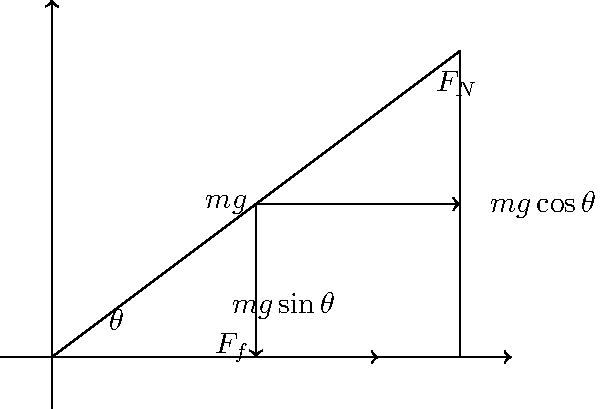In the context of teaching language through literature, consider a story about a refugee's journey up a steep hill. To help students understand the physical challenges faced by the character, explain the forces acting on an object (representing the refugee) on an inclined plane with angle $\theta$. If the coefficient of friction is $\mu$, what is the minimum angle $\theta$ required for the object to slide down the incline? Let's break this down step-by-step:

1) The forces acting on the object are:
   - Gravity ($mg$), acting downward
   - Normal force ($F_N$), perpendicular to the incline
   - Friction force ($F_f$), parallel to the incline and opposing motion

2) We can decompose the gravity force into two components:
   - $mg\sin\theta$ parallel to the incline (down the slope)
   - $mg\cos\theta$ perpendicular to the incline

3) The normal force is equal to the perpendicular component of gravity:
   $F_N = mg\cos\theta$

4) The friction force is given by:
   $F_f = \mu F_N = \mu mg\cos\theta$

5) For the object to be on the verge of sliding, the force down the slope must equal the friction force:
   $mg\sin\theta = \mu mg\cos\theta$

6) Simplifying this equation:
   $\sin\theta = \mu\cos\theta$
   $\tan\theta = \mu$

7) Therefore, the minimum angle for sliding is:
   $\theta = \arctan(\mu)$

This analysis can be used to discuss the challenges faced by the refugee character, relating the physical concept to the narrative and enhancing language learning through scientific context.
Answer: $\theta = \arctan(\mu)$ 